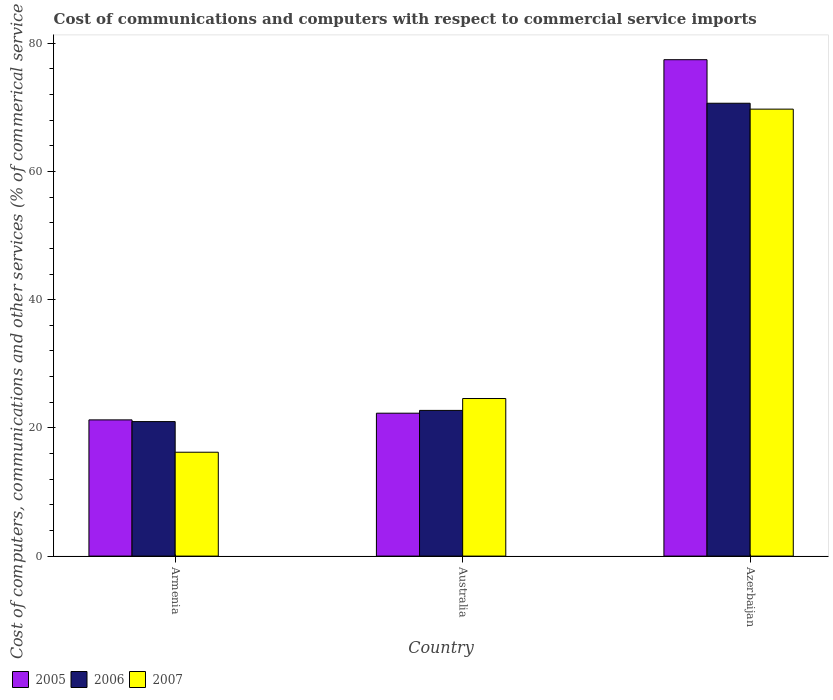How many different coloured bars are there?
Give a very brief answer. 3. Are the number of bars per tick equal to the number of legend labels?
Your response must be concise. Yes. Are the number of bars on each tick of the X-axis equal?
Make the answer very short. Yes. What is the label of the 2nd group of bars from the left?
Give a very brief answer. Australia. What is the cost of communications and computers in 2007 in Azerbaijan?
Ensure brevity in your answer.  69.72. Across all countries, what is the maximum cost of communications and computers in 2006?
Make the answer very short. 70.64. Across all countries, what is the minimum cost of communications and computers in 2005?
Your answer should be compact. 21.25. In which country was the cost of communications and computers in 2006 maximum?
Offer a terse response. Azerbaijan. In which country was the cost of communications and computers in 2005 minimum?
Provide a succinct answer. Armenia. What is the total cost of communications and computers in 2006 in the graph?
Make the answer very short. 114.34. What is the difference between the cost of communications and computers in 2007 in Armenia and that in Azerbaijan?
Keep it short and to the point. -53.52. What is the difference between the cost of communications and computers in 2006 in Armenia and the cost of communications and computers in 2007 in Azerbaijan?
Make the answer very short. -48.74. What is the average cost of communications and computers in 2005 per country?
Your answer should be very brief. 40.32. What is the difference between the cost of communications and computers of/in 2006 and cost of communications and computers of/in 2007 in Australia?
Your answer should be compact. -1.85. In how many countries, is the cost of communications and computers in 2006 greater than 52 %?
Offer a terse response. 1. What is the ratio of the cost of communications and computers in 2006 in Armenia to that in Azerbaijan?
Give a very brief answer. 0.3. Is the cost of communications and computers in 2006 in Armenia less than that in Azerbaijan?
Offer a terse response. Yes. What is the difference between the highest and the second highest cost of communications and computers in 2007?
Offer a terse response. 8.38. What is the difference between the highest and the lowest cost of communications and computers in 2006?
Keep it short and to the point. 49.65. In how many countries, is the cost of communications and computers in 2006 greater than the average cost of communications and computers in 2006 taken over all countries?
Your answer should be very brief. 1. Is the sum of the cost of communications and computers in 2005 in Australia and Azerbaijan greater than the maximum cost of communications and computers in 2006 across all countries?
Ensure brevity in your answer.  Yes. What does the 1st bar from the left in Australia represents?
Offer a terse response. 2005. Is it the case that in every country, the sum of the cost of communications and computers in 2006 and cost of communications and computers in 2007 is greater than the cost of communications and computers in 2005?
Offer a very short reply. Yes. How many bars are there?
Your answer should be compact. 9. Are all the bars in the graph horizontal?
Ensure brevity in your answer.  No. What is the difference between two consecutive major ticks on the Y-axis?
Your answer should be compact. 20. Are the values on the major ticks of Y-axis written in scientific E-notation?
Give a very brief answer. No. Where does the legend appear in the graph?
Give a very brief answer. Bottom left. What is the title of the graph?
Give a very brief answer. Cost of communications and computers with respect to commercial service imports. What is the label or title of the X-axis?
Offer a terse response. Country. What is the label or title of the Y-axis?
Your answer should be very brief. Cost of computers, communications and other services (% of commerical service exports). What is the Cost of computers, communications and other services (% of commerical service exports) of 2005 in Armenia?
Your response must be concise. 21.25. What is the Cost of computers, communications and other services (% of commerical service exports) of 2006 in Armenia?
Keep it short and to the point. 20.98. What is the Cost of computers, communications and other services (% of commerical service exports) in 2007 in Armenia?
Make the answer very short. 16.2. What is the Cost of computers, communications and other services (% of commerical service exports) in 2005 in Australia?
Ensure brevity in your answer.  22.29. What is the Cost of computers, communications and other services (% of commerical service exports) in 2006 in Australia?
Ensure brevity in your answer.  22.72. What is the Cost of computers, communications and other services (% of commerical service exports) in 2007 in Australia?
Offer a very short reply. 24.58. What is the Cost of computers, communications and other services (% of commerical service exports) of 2005 in Azerbaijan?
Provide a short and direct response. 77.43. What is the Cost of computers, communications and other services (% of commerical service exports) in 2006 in Azerbaijan?
Ensure brevity in your answer.  70.64. What is the Cost of computers, communications and other services (% of commerical service exports) in 2007 in Azerbaijan?
Your answer should be compact. 69.72. Across all countries, what is the maximum Cost of computers, communications and other services (% of commerical service exports) in 2005?
Keep it short and to the point. 77.43. Across all countries, what is the maximum Cost of computers, communications and other services (% of commerical service exports) of 2006?
Your response must be concise. 70.64. Across all countries, what is the maximum Cost of computers, communications and other services (% of commerical service exports) in 2007?
Ensure brevity in your answer.  69.72. Across all countries, what is the minimum Cost of computers, communications and other services (% of commerical service exports) in 2005?
Offer a very short reply. 21.25. Across all countries, what is the minimum Cost of computers, communications and other services (% of commerical service exports) in 2006?
Keep it short and to the point. 20.98. Across all countries, what is the minimum Cost of computers, communications and other services (% of commerical service exports) in 2007?
Make the answer very short. 16.2. What is the total Cost of computers, communications and other services (% of commerical service exports) in 2005 in the graph?
Your answer should be very brief. 120.96. What is the total Cost of computers, communications and other services (% of commerical service exports) of 2006 in the graph?
Your response must be concise. 114.34. What is the total Cost of computers, communications and other services (% of commerical service exports) in 2007 in the graph?
Your answer should be compact. 110.49. What is the difference between the Cost of computers, communications and other services (% of commerical service exports) in 2005 in Armenia and that in Australia?
Provide a short and direct response. -1.04. What is the difference between the Cost of computers, communications and other services (% of commerical service exports) in 2006 in Armenia and that in Australia?
Ensure brevity in your answer.  -1.74. What is the difference between the Cost of computers, communications and other services (% of commerical service exports) of 2007 in Armenia and that in Australia?
Ensure brevity in your answer.  -8.38. What is the difference between the Cost of computers, communications and other services (% of commerical service exports) in 2005 in Armenia and that in Azerbaijan?
Offer a terse response. -56.18. What is the difference between the Cost of computers, communications and other services (% of commerical service exports) in 2006 in Armenia and that in Azerbaijan?
Your answer should be very brief. -49.66. What is the difference between the Cost of computers, communications and other services (% of commerical service exports) of 2007 in Armenia and that in Azerbaijan?
Provide a short and direct response. -53.52. What is the difference between the Cost of computers, communications and other services (% of commerical service exports) of 2005 in Australia and that in Azerbaijan?
Give a very brief answer. -55.14. What is the difference between the Cost of computers, communications and other services (% of commerical service exports) of 2006 in Australia and that in Azerbaijan?
Your answer should be compact. -47.91. What is the difference between the Cost of computers, communications and other services (% of commerical service exports) in 2007 in Australia and that in Azerbaijan?
Your answer should be very brief. -45.14. What is the difference between the Cost of computers, communications and other services (% of commerical service exports) of 2005 in Armenia and the Cost of computers, communications and other services (% of commerical service exports) of 2006 in Australia?
Offer a very short reply. -1.48. What is the difference between the Cost of computers, communications and other services (% of commerical service exports) in 2005 in Armenia and the Cost of computers, communications and other services (% of commerical service exports) in 2007 in Australia?
Ensure brevity in your answer.  -3.33. What is the difference between the Cost of computers, communications and other services (% of commerical service exports) of 2006 in Armenia and the Cost of computers, communications and other services (% of commerical service exports) of 2007 in Australia?
Keep it short and to the point. -3.6. What is the difference between the Cost of computers, communications and other services (% of commerical service exports) of 2005 in Armenia and the Cost of computers, communications and other services (% of commerical service exports) of 2006 in Azerbaijan?
Offer a very short reply. -49.39. What is the difference between the Cost of computers, communications and other services (% of commerical service exports) of 2005 in Armenia and the Cost of computers, communications and other services (% of commerical service exports) of 2007 in Azerbaijan?
Your answer should be very brief. -48.47. What is the difference between the Cost of computers, communications and other services (% of commerical service exports) of 2006 in Armenia and the Cost of computers, communications and other services (% of commerical service exports) of 2007 in Azerbaijan?
Ensure brevity in your answer.  -48.74. What is the difference between the Cost of computers, communications and other services (% of commerical service exports) in 2005 in Australia and the Cost of computers, communications and other services (% of commerical service exports) in 2006 in Azerbaijan?
Offer a terse response. -48.35. What is the difference between the Cost of computers, communications and other services (% of commerical service exports) of 2005 in Australia and the Cost of computers, communications and other services (% of commerical service exports) of 2007 in Azerbaijan?
Ensure brevity in your answer.  -47.43. What is the difference between the Cost of computers, communications and other services (% of commerical service exports) in 2006 in Australia and the Cost of computers, communications and other services (% of commerical service exports) in 2007 in Azerbaijan?
Make the answer very short. -46.99. What is the average Cost of computers, communications and other services (% of commerical service exports) in 2005 per country?
Keep it short and to the point. 40.32. What is the average Cost of computers, communications and other services (% of commerical service exports) in 2006 per country?
Offer a terse response. 38.11. What is the average Cost of computers, communications and other services (% of commerical service exports) in 2007 per country?
Offer a very short reply. 36.83. What is the difference between the Cost of computers, communications and other services (% of commerical service exports) of 2005 and Cost of computers, communications and other services (% of commerical service exports) of 2006 in Armenia?
Your answer should be very brief. 0.27. What is the difference between the Cost of computers, communications and other services (% of commerical service exports) of 2005 and Cost of computers, communications and other services (% of commerical service exports) of 2007 in Armenia?
Your response must be concise. 5.05. What is the difference between the Cost of computers, communications and other services (% of commerical service exports) of 2006 and Cost of computers, communications and other services (% of commerical service exports) of 2007 in Armenia?
Give a very brief answer. 4.78. What is the difference between the Cost of computers, communications and other services (% of commerical service exports) of 2005 and Cost of computers, communications and other services (% of commerical service exports) of 2006 in Australia?
Make the answer very short. -0.44. What is the difference between the Cost of computers, communications and other services (% of commerical service exports) in 2005 and Cost of computers, communications and other services (% of commerical service exports) in 2007 in Australia?
Make the answer very short. -2.29. What is the difference between the Cost of computers, communications and other services (% of commerical service exports) in 2006 and Cost of computers, communications and other services (% of commerical service exports) in 2007 in Australia?
Make the answer very short. -1.85. What is the difference between the Cost of computers, communications and other services (% of commerical service exports) of 2005 and Cost of computers, communications and other services (% of commerical service exports) of 2006 in Azerbaijan?
Offer a very short reply. 6.79. What is the difference between the Cost of computers, communications and other services (% of commerical service exports) in 2005 and Cost of computers, communications and other services (% of commerical service exports) in 2007 in Azerbaijan?
Provide a short and direct response. 7.71. What is the difference between the Cost of computers, communications and other services (% of commerical service exports) in 2006 and Cost of computers, communications and other services (% of commerical service exports) in 2007 in Azerbaijan?
Make the answer very short. 0.92. What is the ratio of the Cost of computers, communications and other services (% of commerical service exports) in 2005 in Armenia to that in Australia?
Make the answer very short. 0.95. What is the ratio of the Cost of computers, communications and other services (% of commerical service exports) of 2006 in Armenia to that in Australia?
Offer a terse response. 0.92. What is the ratio of the Cost of computers, communications and other services (% of commerical service exports) in 2007 in Armenia to that in Australia?
Provide a short and direct response. 0.66. What is the ratio of the Cost of computers, communications and other services (% of commerical service exports) in 2005 in Armenia to that in Azerbaijan?
Your response must be concise. 0.27. What is the ratio of the Cost of computers, communications and other services (% of commerical service exports) in 2006 in Armenia to that in Azerbaijan?
Offer a terse response. 0.3. What is the ratio of the Cost of computers, communications and other services (% of commerical service exports) in 2007 in Armenia to that in Azerbaijan?
Offer a very short reply. 0.23. What is the ratio of the Cost of computers, communications and other services (% of commerical service exports) of 2005 in Australia to that in Azerbaijan?
Give a very brief answer. 0.29. What is the ratio of the Cost of computers, communications and other services (% of commerical service exports) in 2006 in Australia to that in Azerbaijan?
Offer a very short reply. 0.32. What is the ratio of the Cost of computers, communications and other services (% of commerical service exports) of 2007 in Australia to that in Azerbaijan?
Your answer should be very brief. 0.35. What is the difference between the highest and the second highest Cost of computers, communications and other services (% of commerical service exports) of 2005?
Your response must be concise. 55.14. What is the difference between the highest and the second highest Cost of computers, communications and other services (% of commerical service exports) in 2006?
Your answer should be very brief. 47.91. What is the difference between the highest and the second highest Cost of computers, communications and other services (% of commerical service exports) of 2007?
Your answer should be very brief. 45.14. What is the difference between the highest and the lowest Cost of computers, communications and other services (% of commerical service exports) in 2005?
Your response must be concise. 56.18. What is the difference between the highest and the lowest Cost of computers, communications and other services (% of commerical service exports) of 2006?
Keep it short and to the point. 49.66. What is the difference between the highest and the lowest Cost of computers, communications and other services (% of commerical service exports) in 2007?
Keep it short and to the point. 53.52. 